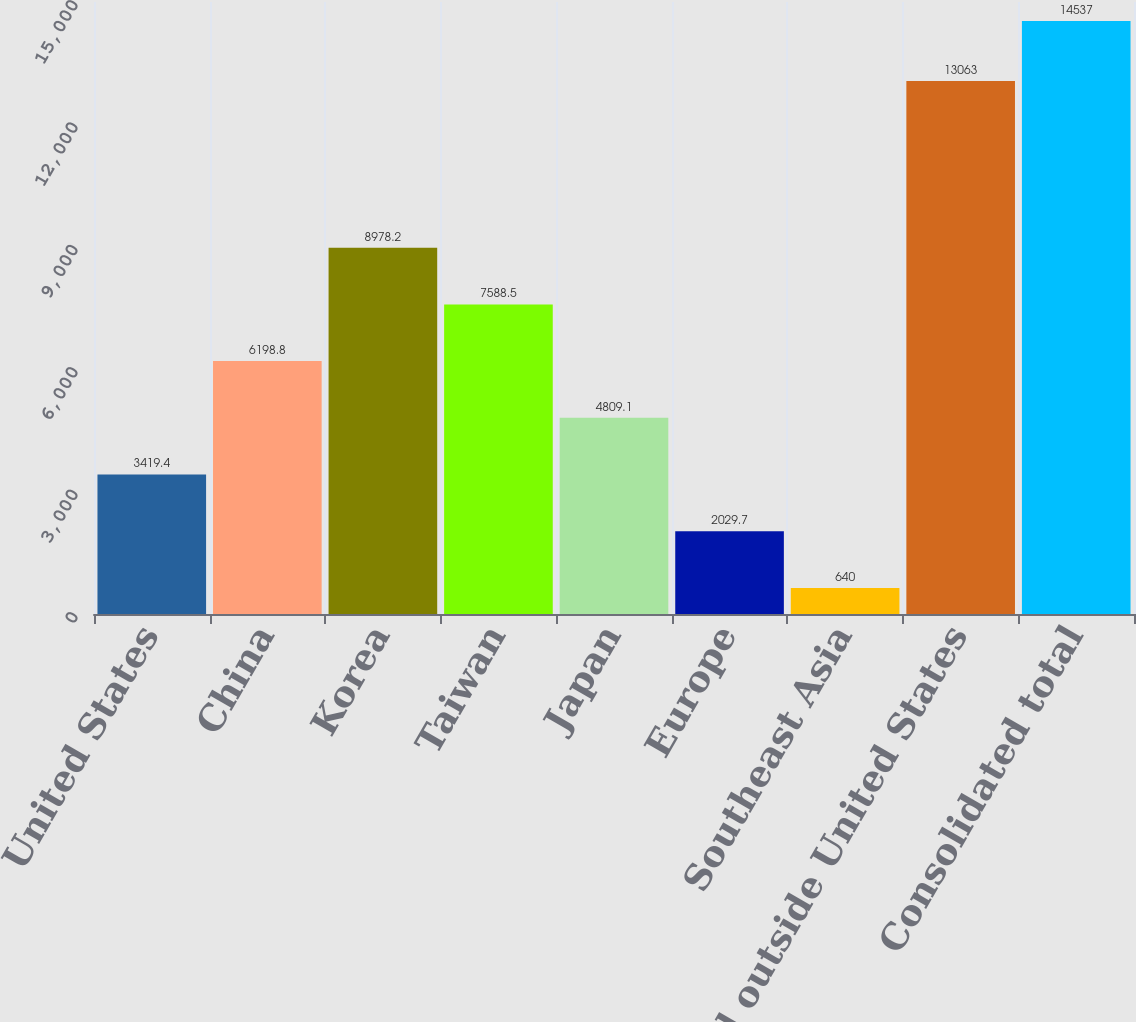Convert chart to OTSL. <chart><loc_0><loc_0><loc_500><loc_500><bar_chart><fcel>United States<fcel>China<fcel>Korea<fcel>Taiwan<fcel>Japan<fcel>Europe<fcel>Southeast Asia<fcel>Total outside United States<fcel>Consolidated total<nl><fcel>3419.4<fcel>6198.8<fcel>8978.2<fcel>7588.5<fcel>4809.1<fcel>2029.7<fcel>640<fcel>13063<fcel>14537<nl></chart> 